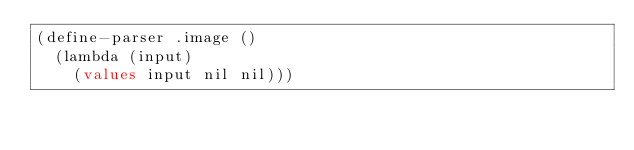Convert code to text. <code><loc_0><loc_0><loc_500><loc_500><_Lisp_>(define-parser .image ()
  (lambda (input)
    (values input nil nil)))
</code> 